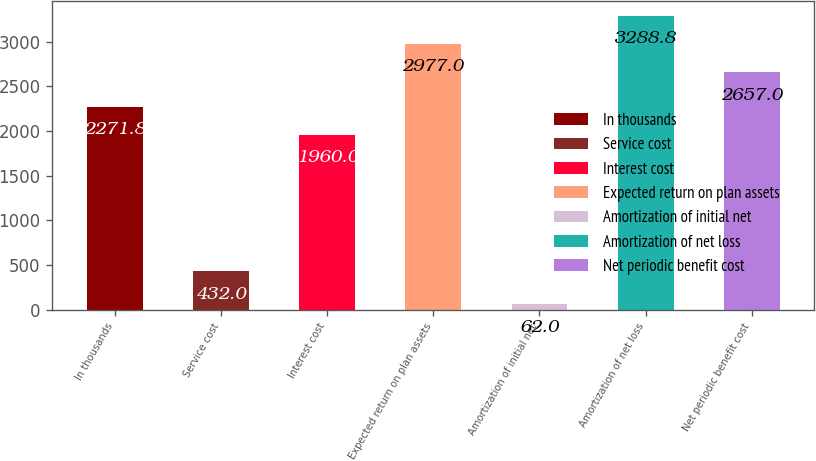Convert chart to OTSL. <chart><loc_0><loc_0><loc_500><loc_500><bar_chart><fcel>In thousands<fcel>Service cost<fcel>Interest cost<fcel>Expected return on plan assets<fcel>Amortization of initial net<fcel>Amortization of net loss<fcel>Net periodic benefit cost<nl><fcel>2271.8<fcel>432<fcel>1960<fcel>2977<fcel>62<fcel>3288.8<fcel>2657<nl></chart> 